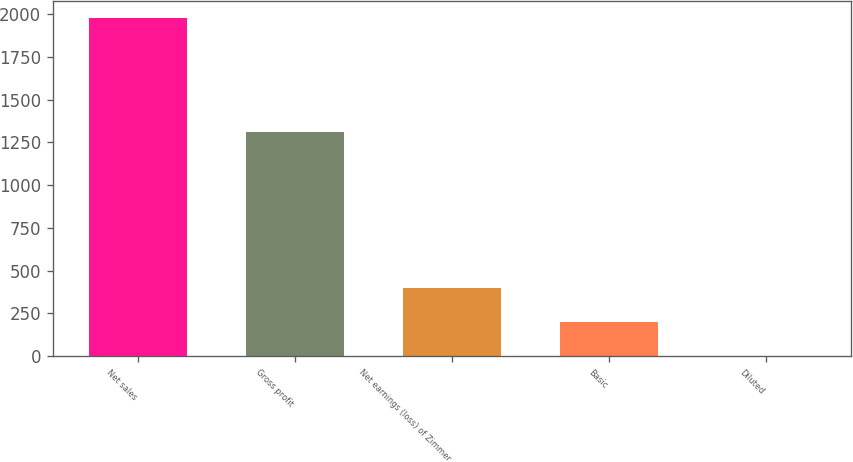Convert chart to OTSL. <chart><loc_0><loc_0><loc_500><loc_500><bar_chart><fcel>Net sales<fcel>Gross profit<fcel>Net earnings (loss) of Zimmer<fcel>Basic<fcel>Diluted<nl><fcel>1977.3<fcel>1312.4<fcel>396.63<fcel>199.05<fcel>1.47<nl></chart> 